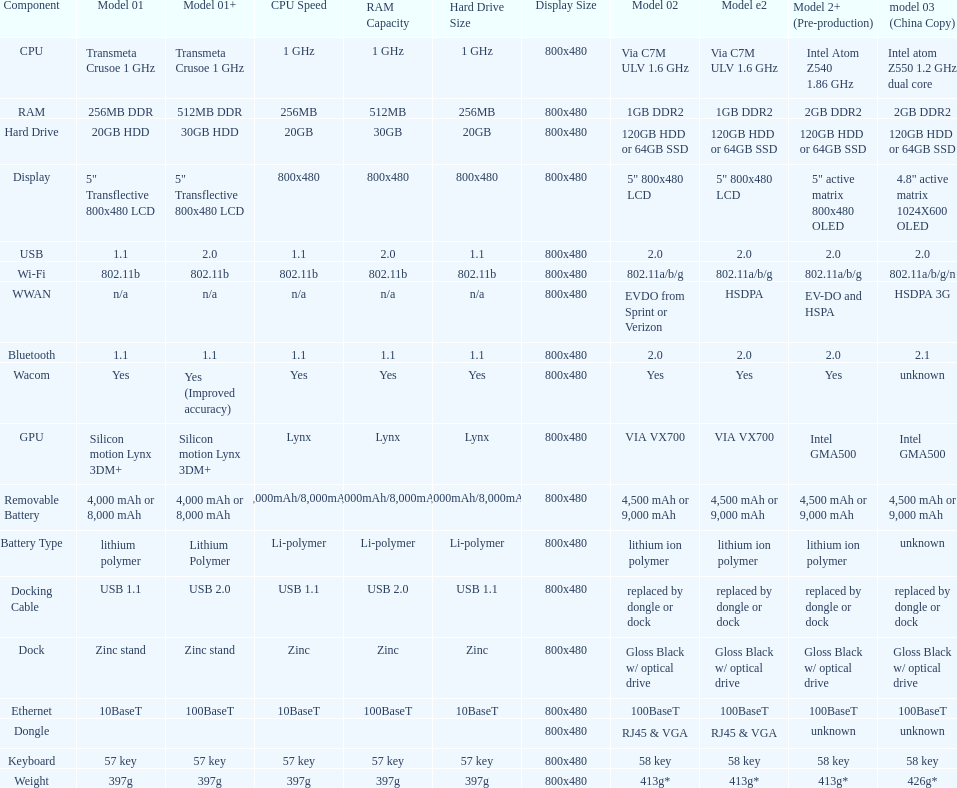What is the total number of components on the chart? 18. 